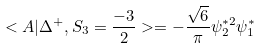<formula> <loc_0><loc_0><loc_500><loc_500>< A | \Delta ^ { + } , S _ { 3 } = \frac { - 3 } { 2 } > = - \frac { \sqrt { 6 } } { \pi } \psi _ { 2 } ^ { * 2 } \psi _ { 1 } ^ { * }</formula> 